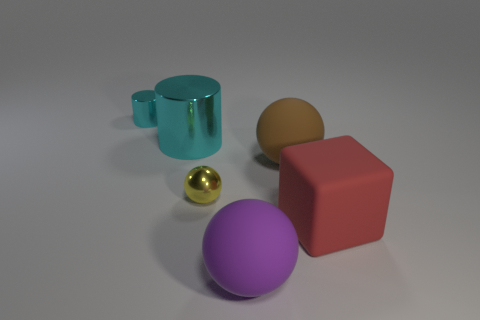Subtract all brown rubber spheres. How many spheres are left? 2 Add 1 cylinders. How many objects exist? 7 Subtract 1 cylinders. How many cylinders are left? 1 Subtract all purple balls. How many balls are left? 2 Subtract all cubes. How many objects are left? 5 Subtract all green balls. Subtract all cyan shiny cylinders. How many objects are left? 4 Add 5 big red things. How many big red things are left? 6 Add 4 tiny cyan metallic objects. How many tiny cyan metallic objects exist? 5 Subtract 0 blue balls. How many objects are left? 6 Subtract all blue blocks. Subtract all purple cylinders. How many blocks are left? 1 